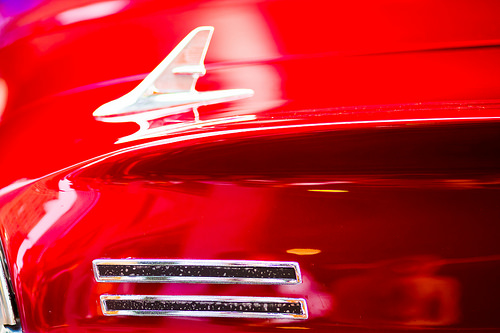<image>
Is there a ornament above the hood? Yes. The ornament is positioned above the hood in the vertical space, higher up in the scene. 